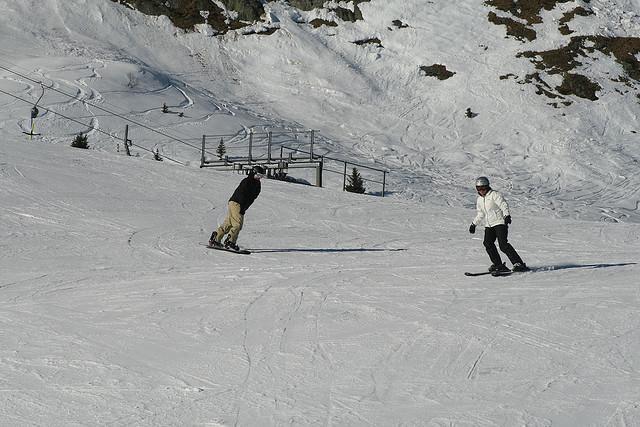How many people are there?
Give a very brief answer. 2. How many people are shown?
Give a very brief answer. 2. 